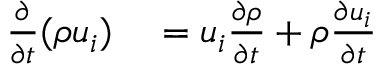<formula> <loc_0><loc_0><loc_500><loc_500>\begin{array} { r l } { { \frac { \partial } { \partial t } } ( \rho u _ { i } ) } & = u _ { i } { \frac { \partial \rho } { \partial t } } + \rho { \frac { \partial u _ { i } } { \partial t } } } \end{array}</formula> 